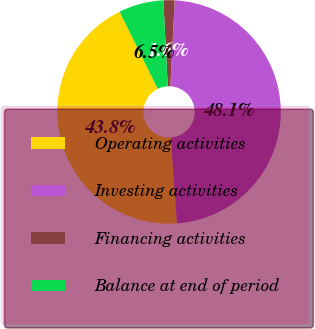Convert chart. <chart><loc_0><loc_0><loc_500><loc_500><pie_chart><fcel>Operating activities<fcel>Investing activities<fcel>Financing activities<fcel>Balance at end of period<nl><fcel>43.83%<fcel>48.05%<fcel>1.62%<fcel>6.49%<nl></chart> 